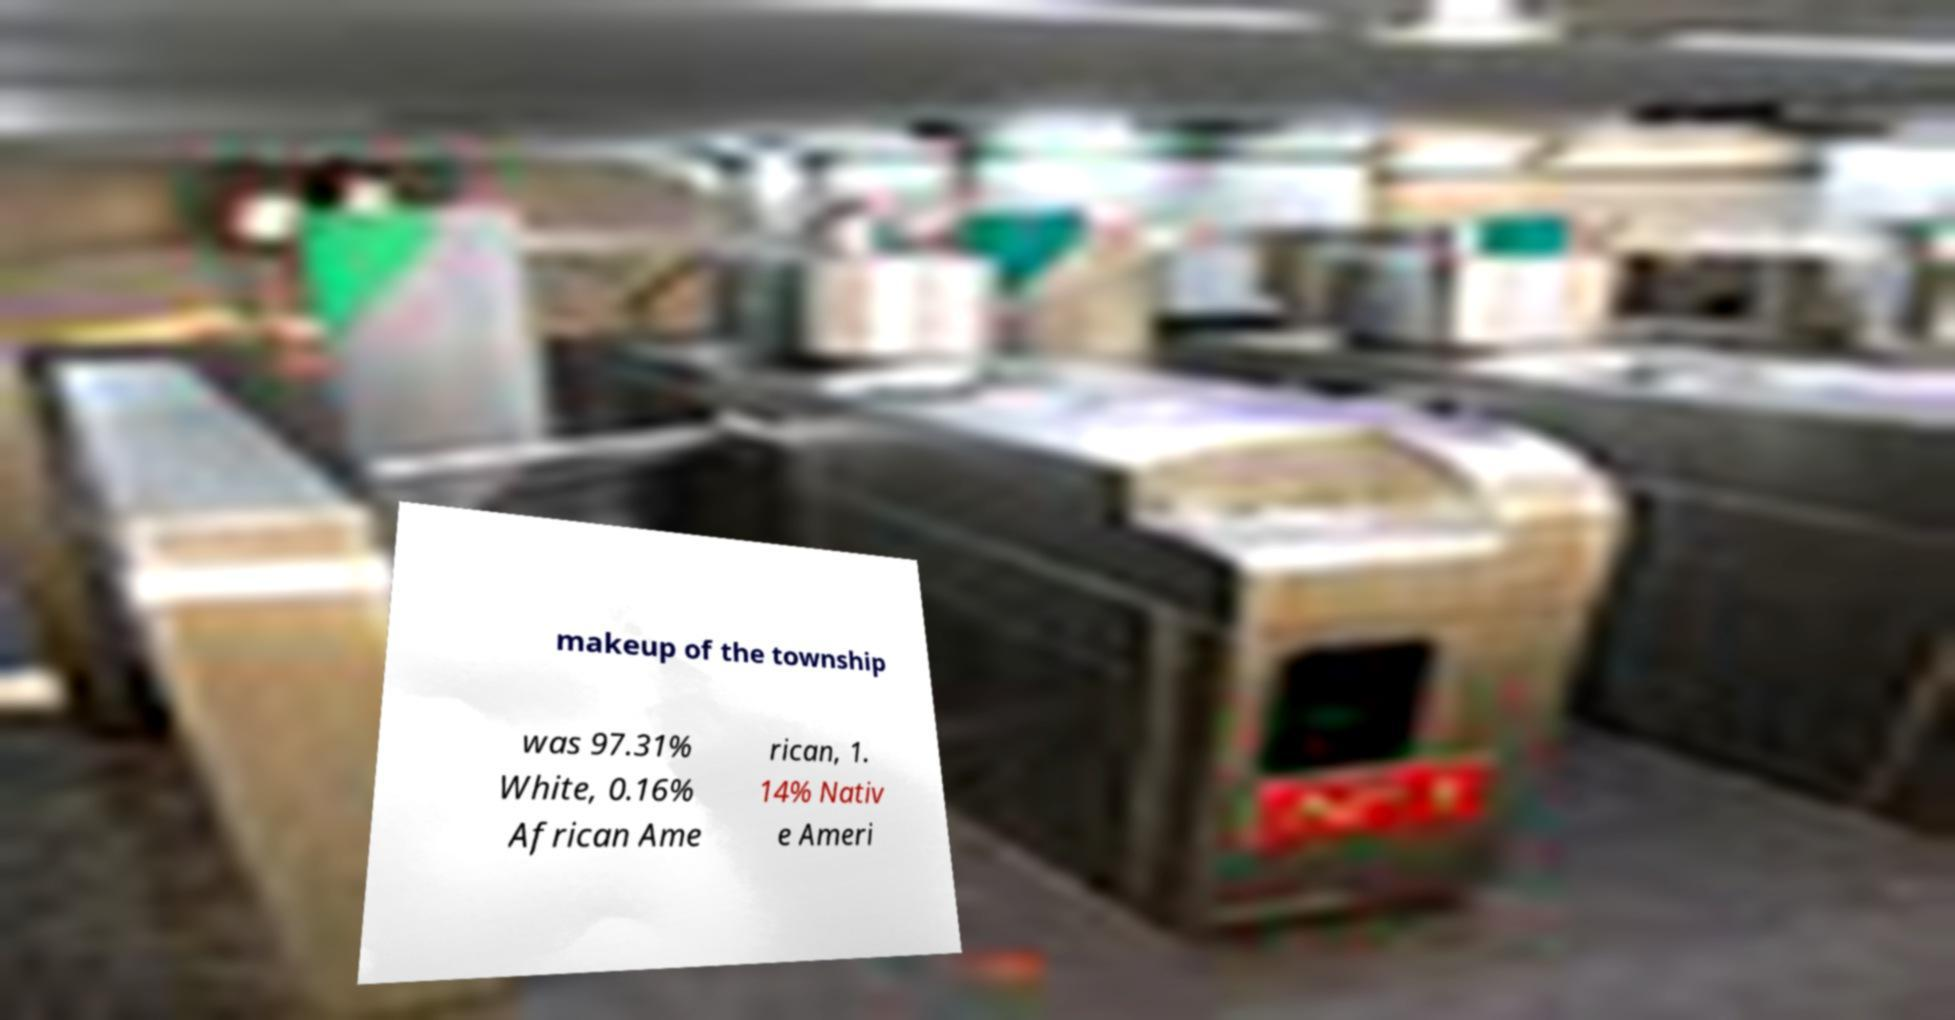Can you read and provide the text displayed in the image?This photo seems to have some interesting text. Can you extract and type it out for me? makeup of the township was 97.31% White, 0.16% African Ame rican, 1. 14% Nativ e Ameri 